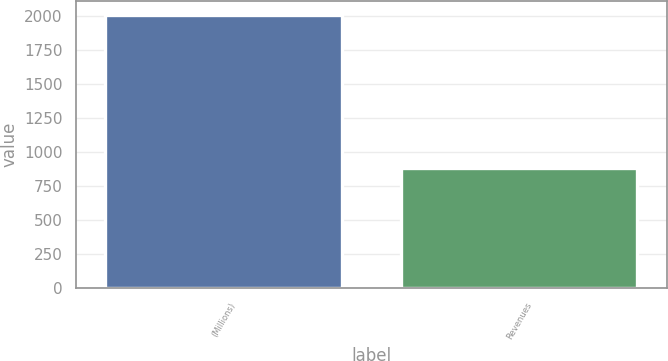Convert chart to OTSL. <chart><loc_0><loc_0><loc_500><loc_500><bar_chart><fcel>(Millions)<fcel>Revenues<nl><fcel>2008<fcel>885<nl></chart> 